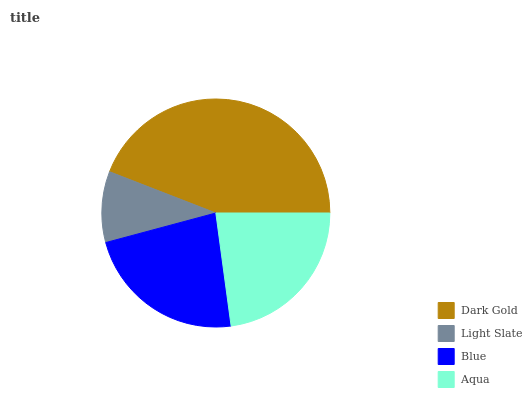Is Light Slate the minimum?
Answer yes or no. Yes. Is Dark Gold the maximum?
Answer yes or no. Yes. Is Blue the minimum?
Answer yes or no. No. Is Blue the maximum?
Answer yes or no. No. Is Blue greater than Light Slate?
Answer yes or no. Yes. Is Light Slate less than Blue?
Answer yes or no. Yes. Is Light Slate greater than Blue?
Answer yes or no. No. Is Blue less than Light Slate?
Answer yes or no. No. Is Blue the high median?
Answer yes or no. Yes. Is Aqua the low median?
Answer yes or no. Yes. Is Dark Gold the high median?
Answer yes or no. No. Is Blue the low median?
Answer yes or no. No. 